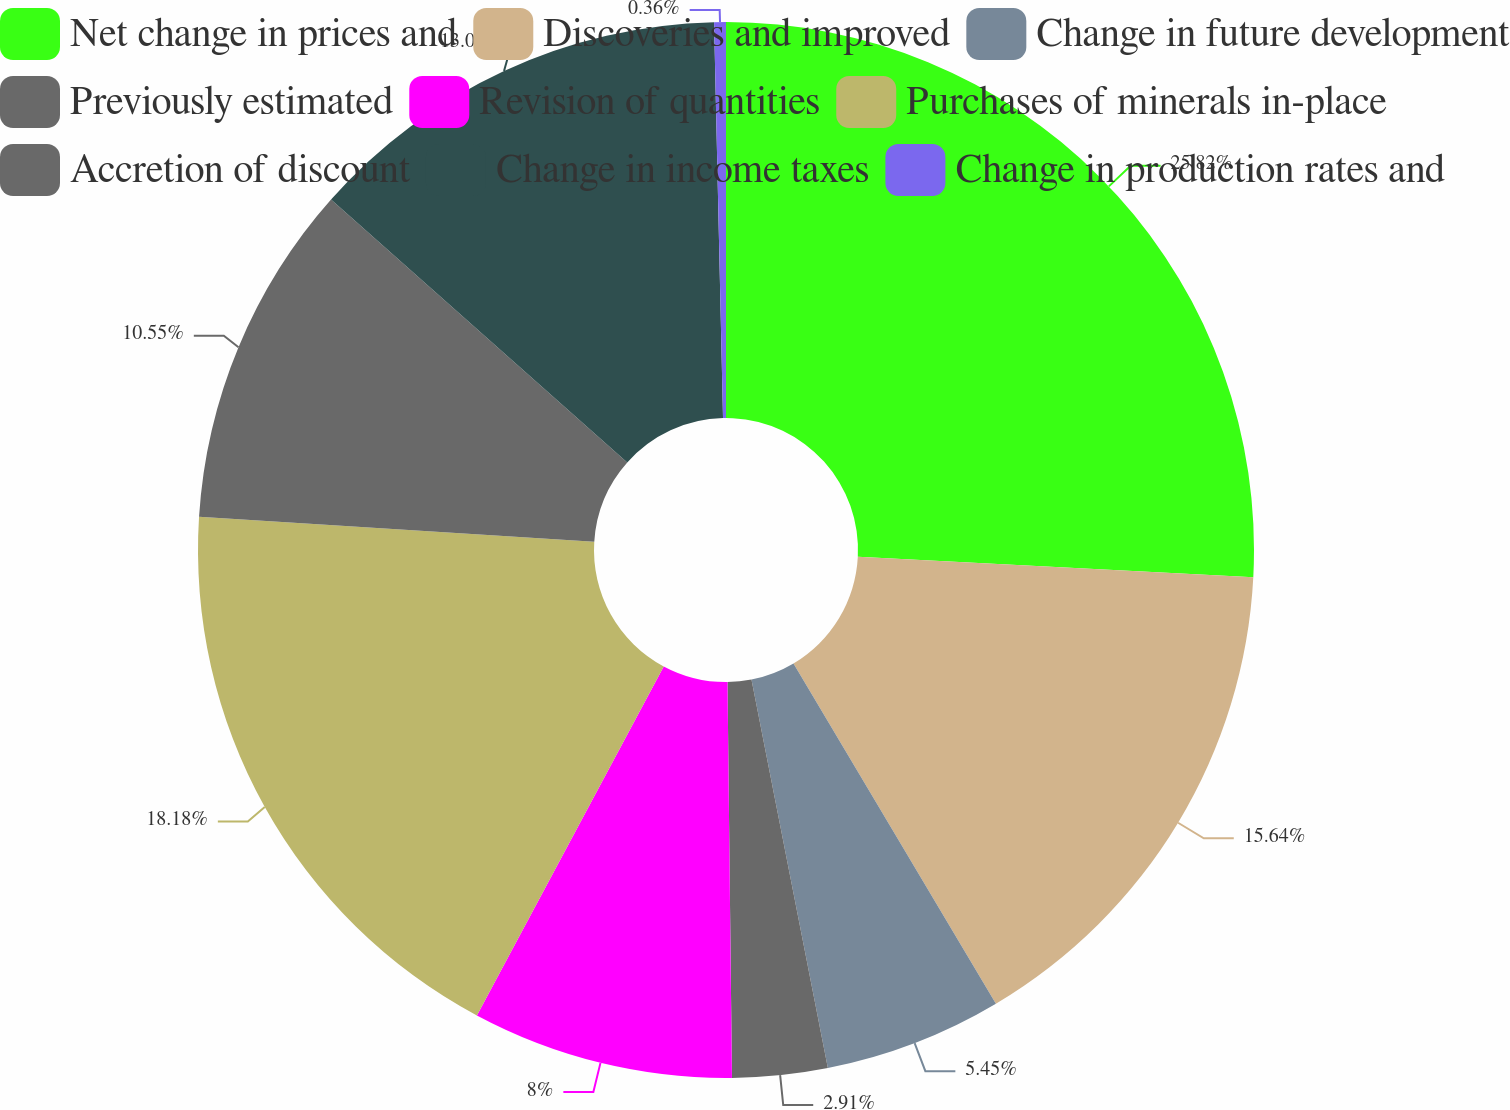<chart> <loc_0><loc_0><loc_500><loc_500><pie_chart><fcel>Net change in prices and<fcel>Discoveries and improved<fcel>Change in future development<fcel>Previously estimated<fcel>Revision of quantities<fcel>Purchases of minerals in-place<fcel>Accretion of discount<fcel>Change in income taxes<fcel>Change in production rates and<nl><fcel>25.82%<fcel>15.64%<fcel>5.45%<fcel>2.91%<fcel>8.0%<fcel>18.18%<fcel>10.55%<fcel>13.09%<fcel>0.36%<nl></chart> 